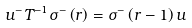Convert formula to latex. <formula><loc_0><loc_0><loc_500><loc_500>u ^ { - } T ^ { - 1 } \sigma ^ { - } \left ( r \right ) = \sigma ^ { - } \left ( r - 1 \right ) u \</formula> 